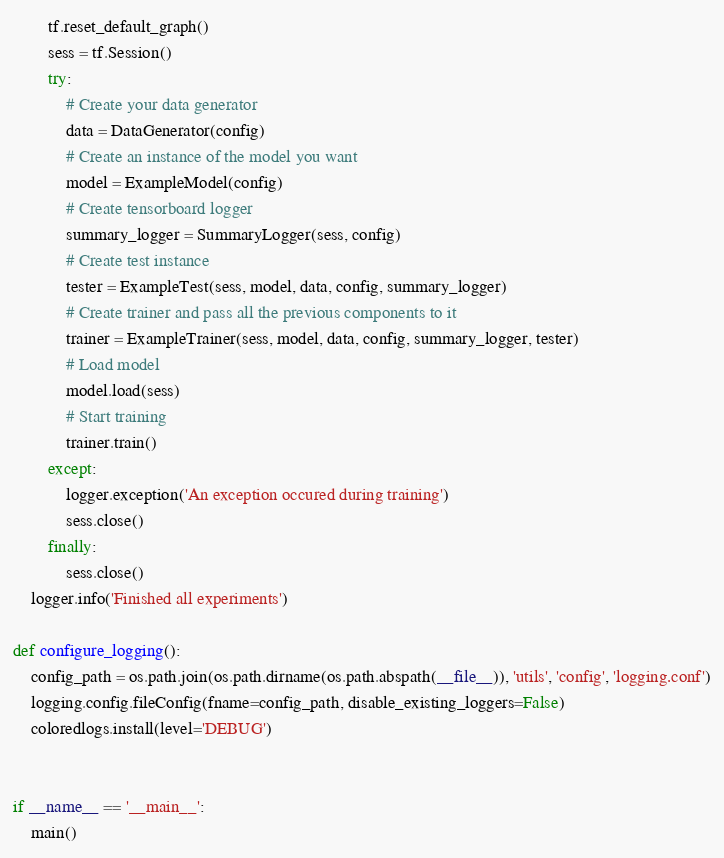Convert code to text. <code><loc_0><loc_0><loc_500><loc_500><_Python_>        tf.reset_default_graph()
        sess = tf.Session()
        try:
            # Create your data generator
            data = DataGenerator(config)
            # Create an instance of the model you want
            model = ExampleModel(config)
            # Create tensorboard logger
            summary_logger = SummaryLogger(sess, config)
            # Create test instance
            tester = ExampleTest(sess, model, data, config, summary_logger)
            # Create trainer and pass all the previous components to it
            trainer = ExampleTrainer(sess, model, data, config, summary_logger, tester)
            # Load model
            model.load(sess)
            # Start training
            trainer.train()
        except:
            logger.exception('An exception occured during training')
            sess.close()
        finally:
            sess.close()
    logger.info('Finished all experiments')

def configure_logging():
    config_path = os.path.join(os.path.dirname(os.path.abspath(__file__)), 'utils', 'config', 'logging.conf')
    logging.config.fileConfig(fname=config_path, disable_existing_loggers=False)
    coloredlogs.install(level='DEBUG')


if __name__ == '__main__':
    main()
</code> 